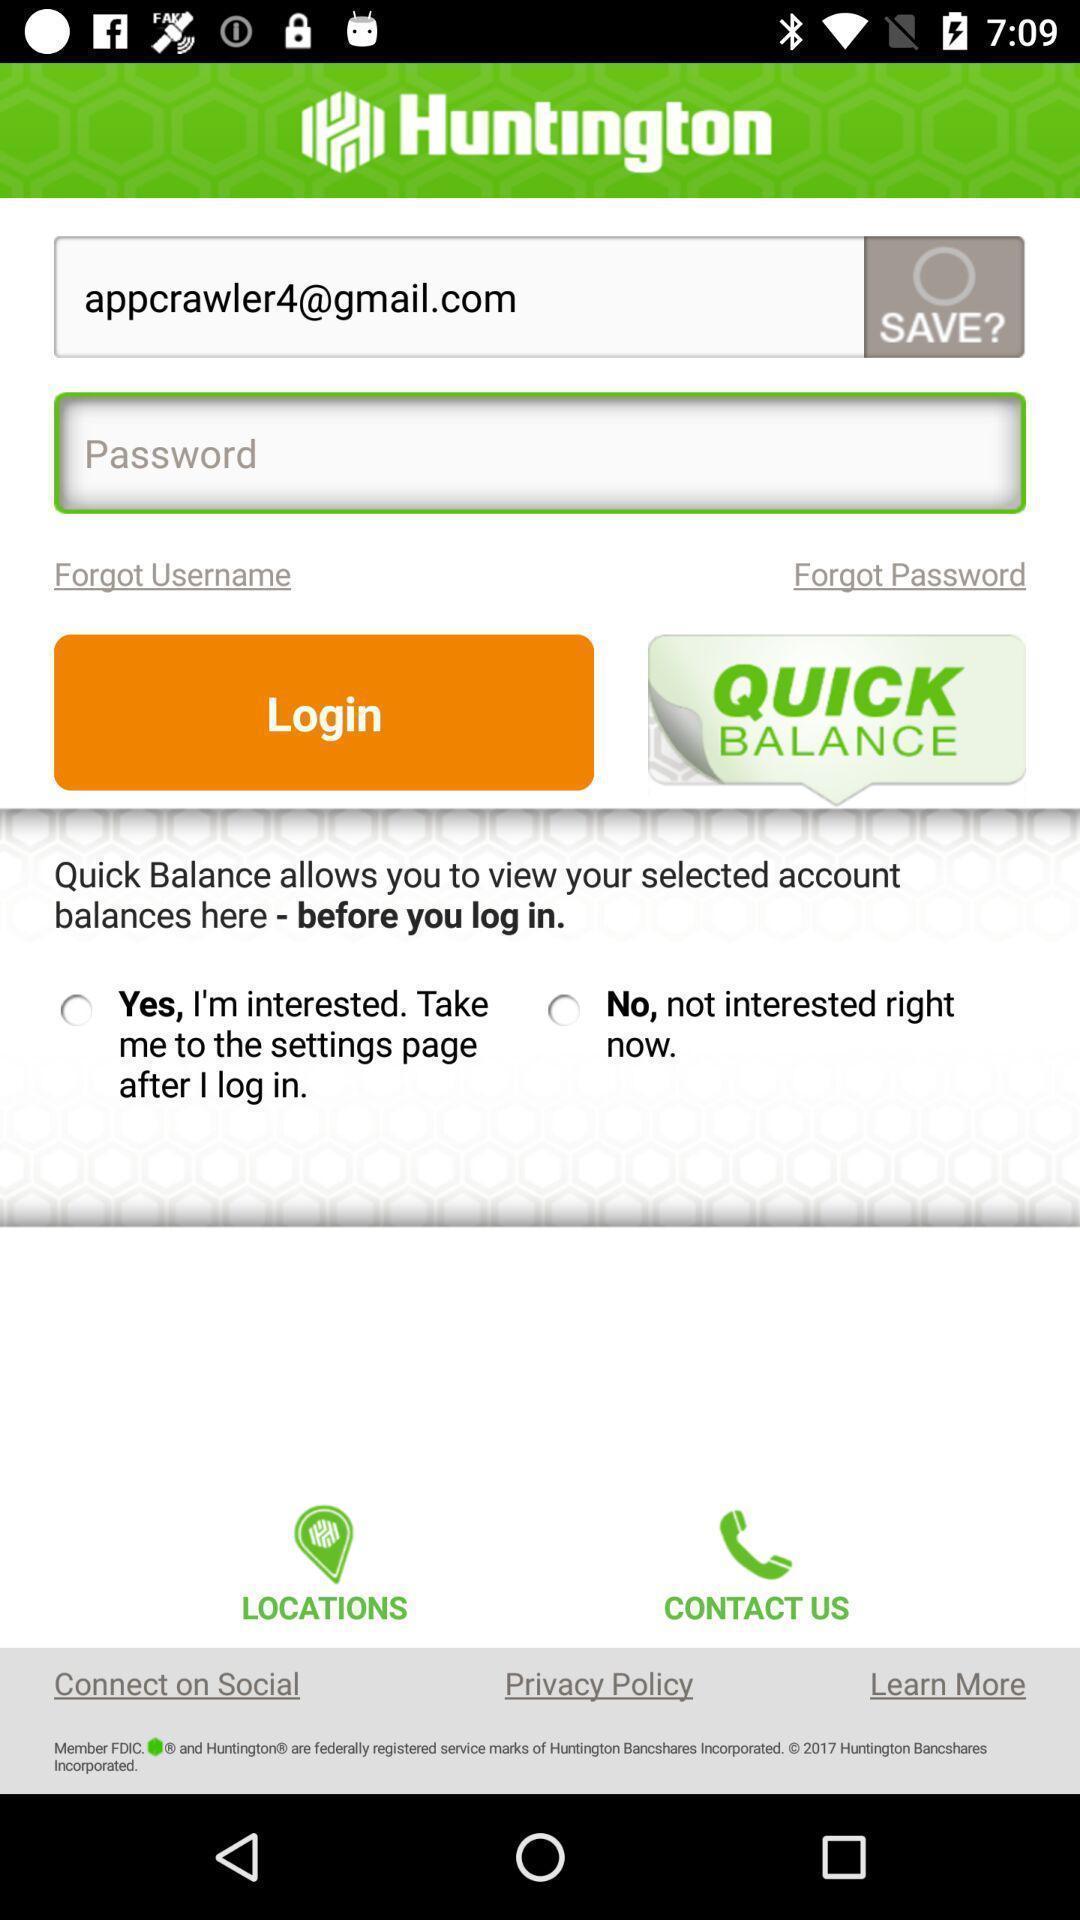Summarize the information in this screenshot. Screen displays the login page of a banking app. 